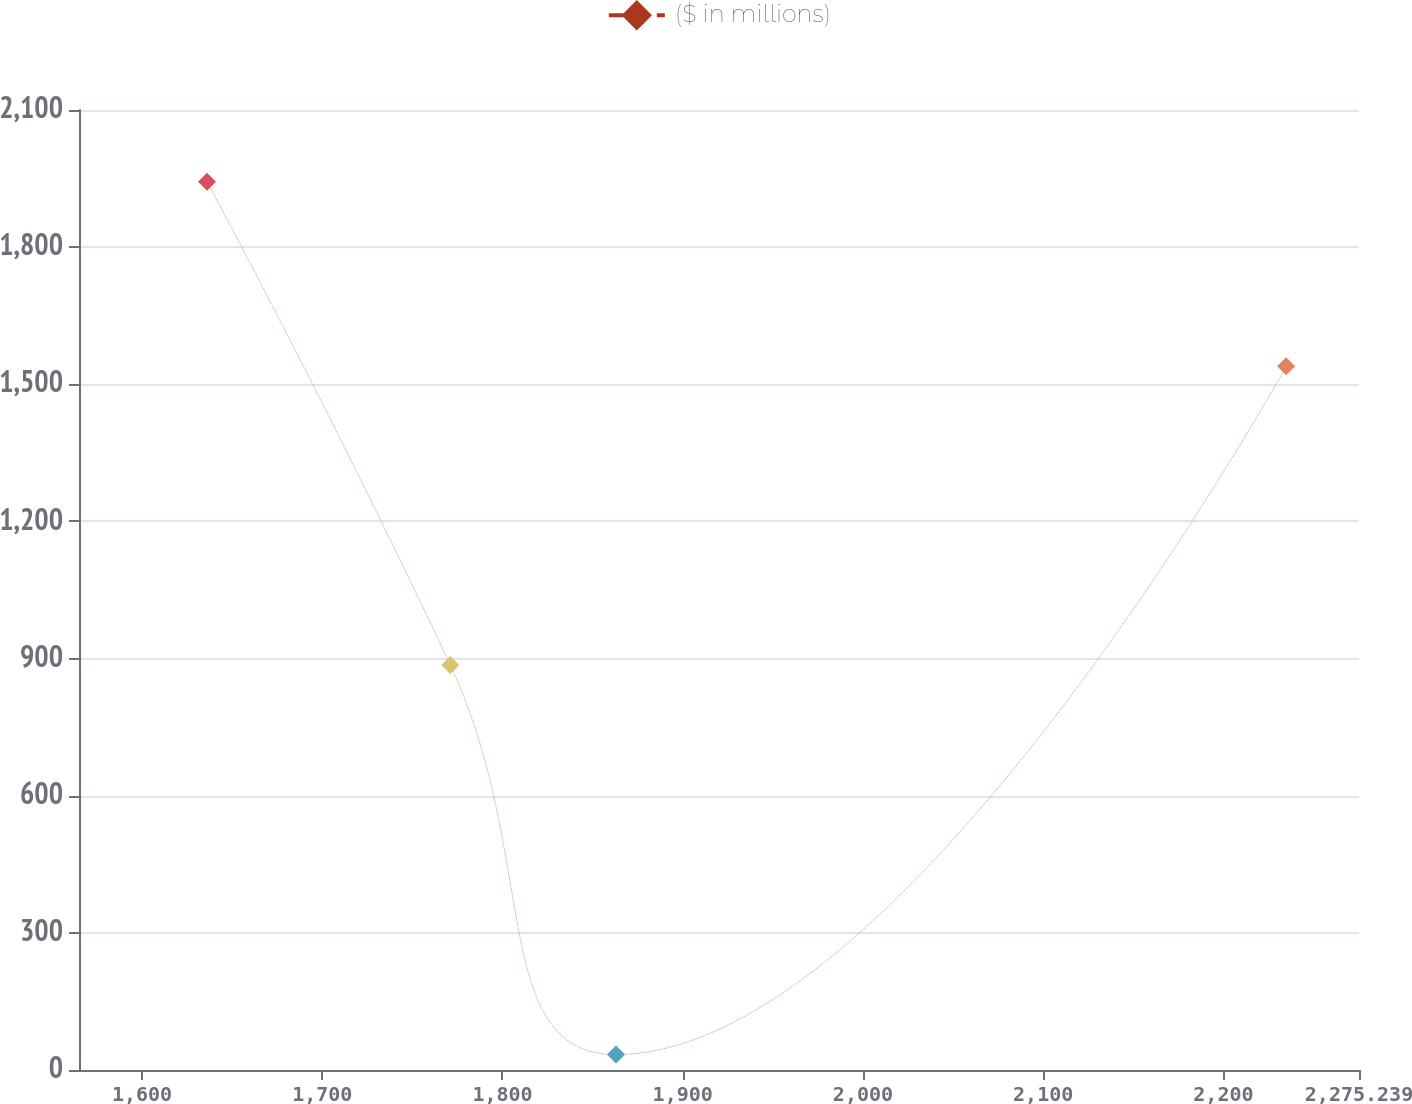Convert chart to OTSL. <chart><loc_0><loc_0><loc_500><loc_500><line_chart><ecel><fcel>($ in millions)<nl><fcel>1636.05<fcel>1943.32<nl><fcel>1771.01<fcel>886.07<nl><fcel>1863<fcel>33.87<nl><fcel>2234.82<fcel>1539.41<nl><fcel>2346.26<fcel>224.82<nl></chart> 